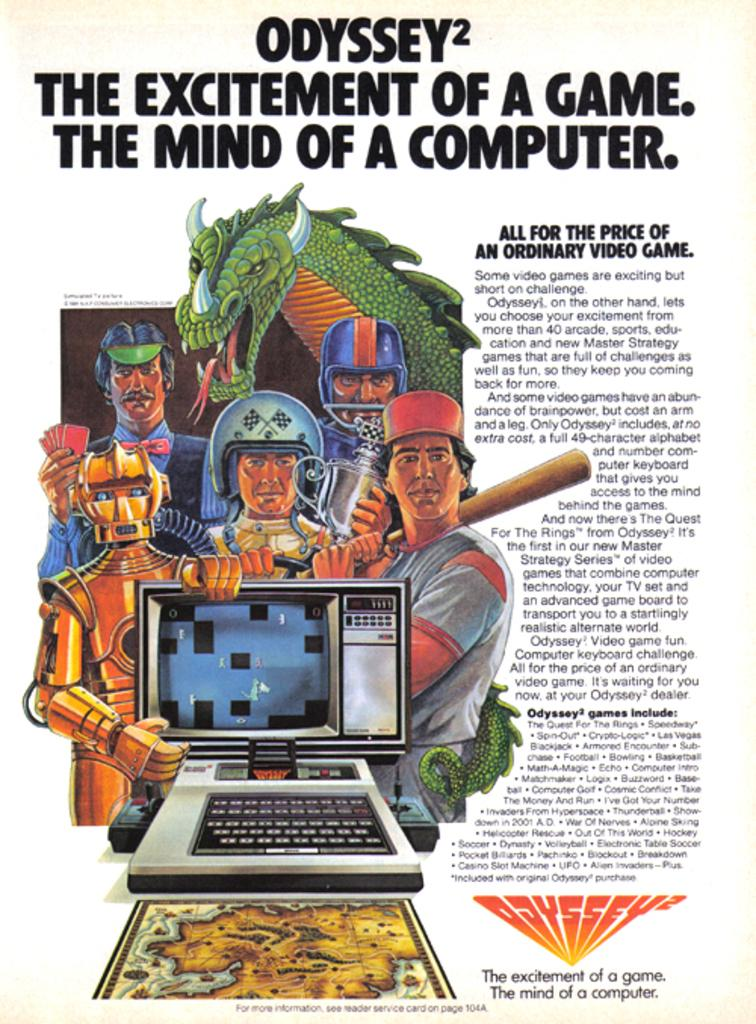<image>
Share a concise interpretation of the image provided. An advertisement for an Odyssey video game system 